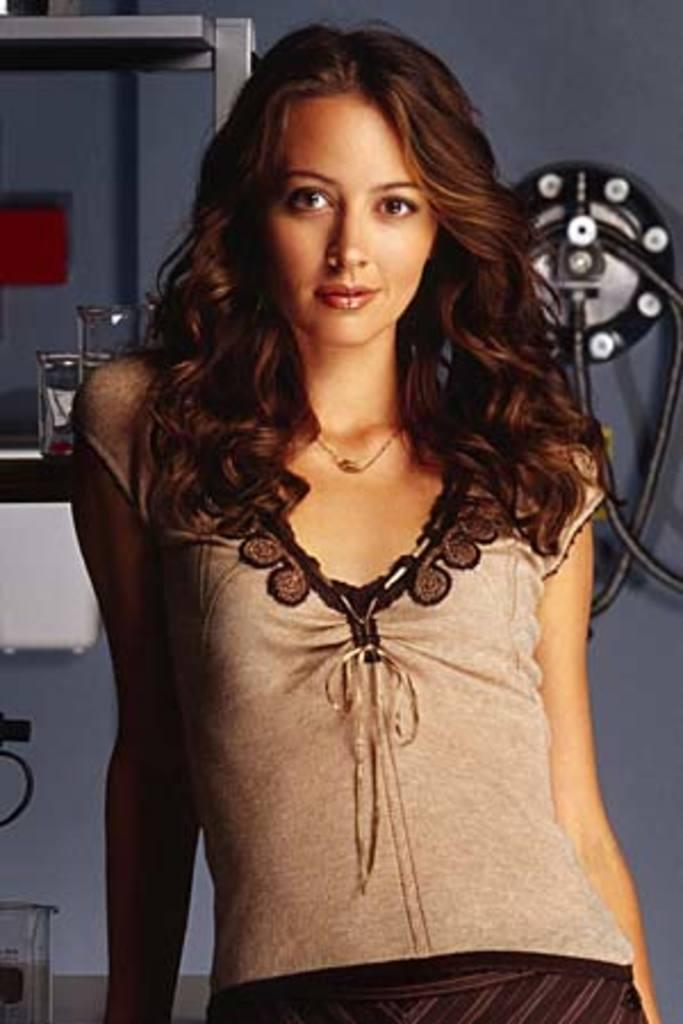Who is present in the image? There is a woman in the image. What expression does the woman have? The woman is smiling. What can be seen in the background of the image? There is a wall and objects in the background of the image. Can you see the woman's bat in the image? There is no bat present in the image. Is the woman kicking anything in the image? There is no indication in the image that the woman is kicking anything. 